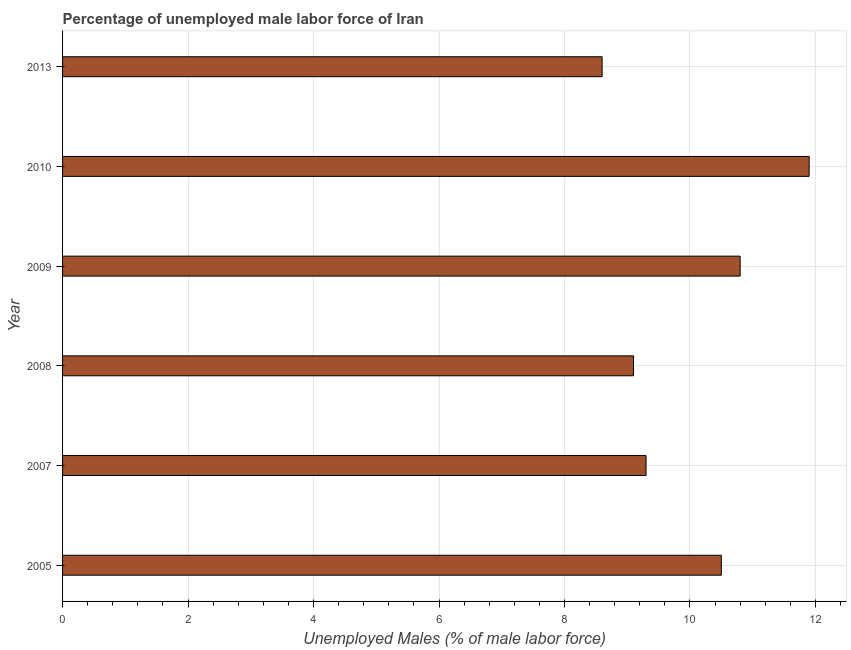What is the title of the graph?
Your response must be concise. Percentage of unemployed male labor force of Iran. What is the label or title of the X-axis?
Your answer should be compact. Unemployed Males (% of male labor force). What is the total unemployed male labour force in 2013?
Offer a terse response. 8.6. Across all years, what is the maximum total unemployed male labour force?
Keep it short and to the point. 11.9. Across all years, what is the minimum total unemployed male labour force?
Keep it short and to the point. 8.6. In which year was the total unemployed male labour force maximum?
Offer a terse response. 2010. What is the sum of the total unemployed male labour force?
Your response must be concise. 60.2. What is the average total unemployed male labour force per year?
Provide a short and direct response. 10.03. What is the median total unemployed male labour force?
Provide a succinct answer. 9.9. Do a majority of the years between 2010 and 2007 (inclusive) have total unemployed male labour force greater than 10.4 %?
Provide a succinct answer. Yes. What is the ratio of the total unemployed male labour force in 2008 to that in 2010?
Offer a very short reply. 0.77. What is the difference between the highest and the second highest total unemployed male labour force?
Provide a succinct answer. 1.1. What is the difference between the highest and the lowest total unemployed male labour force?
Your answer should be compact. 3.3. How many bars are there?
Provide a short and direct response. 6. What is the difference between two consecutive major ticks on the X-axis?
Make the answer very short. 2. Are the values on the major ticks of X-axis written in scientific E-notation?
Keep it short and to the point. No. What is the Unemployed Males (% of male labor force) in 2005?
Provide a succinct answer. 10.5. What is the Unemployed Males (% of male labor force) of 2007?
Keep it short and to the point. 9.3. What is the Unemployed Males (% of male labor force) of 2008?
Keep it short and to the point. 9.1. What is the Unemployed Males (% of male labor force) in 2009?
Offer a very short reply. 10.8. What is the Unemployed Males (% of male labor force) of 2010?
Provide a succinct answer. 11.9. What is the Unemployed Males (% of male labor force) of 2013?
Keep it short and to the point. 8.6. What is the difference between the Unemployed Males (% of male labor force) in 2005 and 2007?
Your response must be concise. 1.2. What is the difference between the Unemployed Males (% of male labor force) in 2005 and 2008?
Provide a short and direct response. 1.4. What is the difference between the Unemployed Males (% of male labor force) in 2005 and 2009?
Provide a succinct answer. -0.3. What is the difference between the Unemployed Males (% of male labor force) in 2005 and 2010?
Your answer should be compact. -1.4. What is the difference between the Unemployed Males (% of male labor force) in 2005 and 2013?
Keep it short and to the point. 1.9. What is the difference between the Unemployed Males (% of male labor force) in 2007 and 2010?
Keep it short and to the point. -2.6. What is the difference between the Unemployed Males (% of male labor force) in 2007 and 2013?
Provide a short and direct response. 0.7. What is the difference between the Unemployed Males (% of male labor force) in 2008 and 2009?
Make the answer very short. -1.7. What is the difference between the Unemployed Males (% of male labor force) in 2008 and 2013?
Provide a short and direct response. 0.5. What is the difference between the Unemployed Males (% of male labor force) in 2009 and 2010?
Provide a succinct answer. -1.1. What is the difference between the Unemployed Males (% of male labor force) in 2010 and 2013?
Make the answer very short. 3.3. What is the ratio of the Unemployed Males (% of male labor force) in 2005 to that in 2007?
Keep it short and to the point. 1.13. What is the ratio of the Unemployed Males (% of male labor force) in 2005 to that in 2008?
Give a very brief answer. 1.15. What is the ratio of the Unemployed Males (% of male labor force) in 2005 to that in 2009?
Your response must be concise. 0.97. What is the ratio of the Unemployed Males (% of male labor force) in 2005 to that in 2010?
Your response must be concise. 0.88. What is the ratio of the Unemployed Males (% of male labor force) in 2005 to that in 2013?
Offer a very short reply. 1.22. What is the ratio of the Unemployed Males (% of male labor force) in 2007 to that in 2008?
Offer a terse response. 1.02. What is the ratio of the Unemployed Males (% of male labor force) in 2007 to that in 2009?
Your answer should be very brief. 0.86. What is the ratio of the Unemployed Males (% of male labor force) in 2007 to that in 2010?
Your response must be concise. 0.78. What is the ratio of the Unemployed Males (% of male labor force) in 2007 to that in 2013?
Provide a succinct answer. 1.08. What is the ratio of the Unemployed Males (% of male labor force) in 2008 to that in 2009?
Make the answer very short. 0.84. What is the ratio of the Unemployed Males (% of male labor force) in 2008 to that in 2010?
Make the answer very short. 0.77. What is the ratio of the Unemployed Males (% of male labor force) in 2008 to that in 2013?
Provide a short and direct response. 1.06. What is the ratio of the Unemployed Males (% of male labor force) in 2009 to that in 2010?
Make the answer very short. 0.91. What is the ratio of the Unemployed Males (% of male labor force) in 2009 to that in 2013?
Offer a terse response. 1.26. What is the ratio of the Unemployed Males (% of male labor force) in 2010 to that in 2013?
Your answer should be compact. 1.38. 